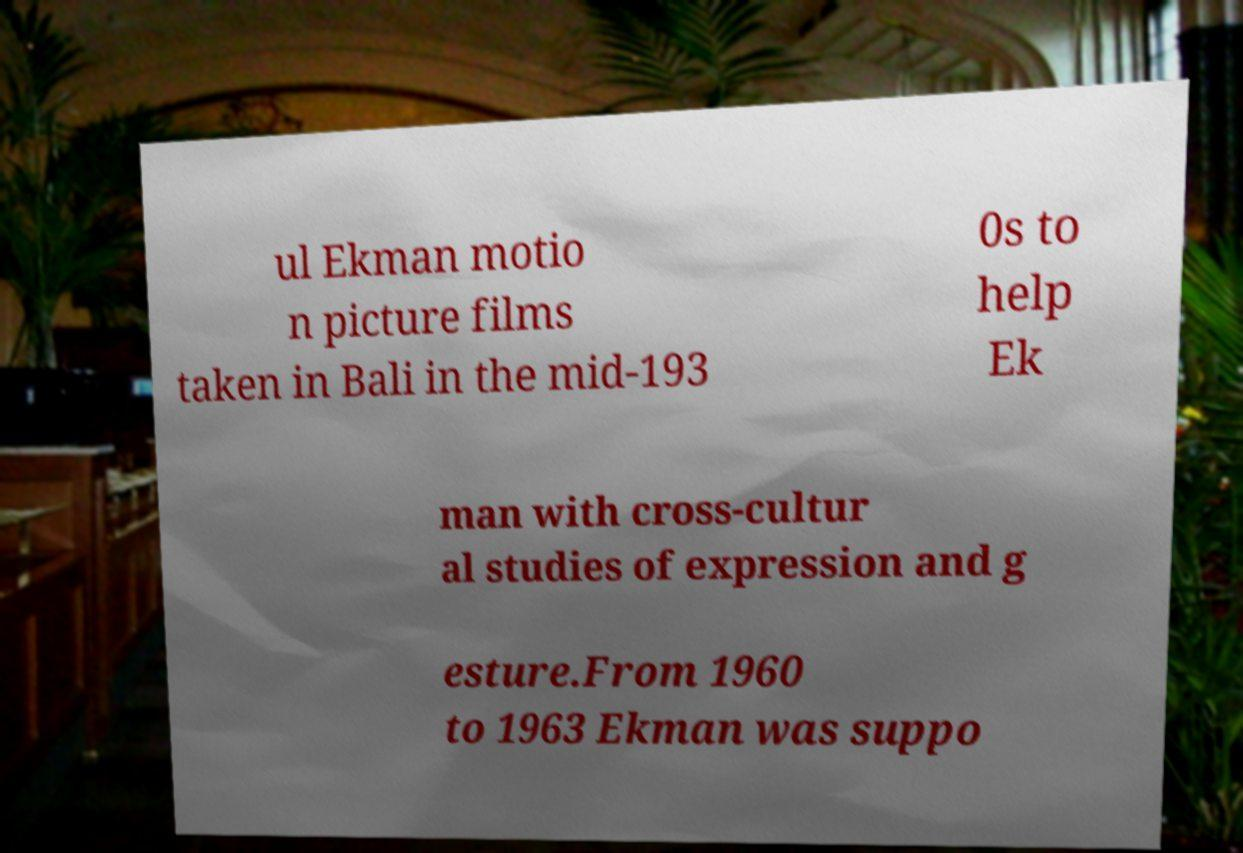Could you assist in decoding the text presented in this image and type it out clearly? ul Ekman motio n picture films taken in Bali in the mid-193 0s to help Ek man with cross-cultur al studies of expression and g esture.From 1960 to 1963 Ekman was suppo 